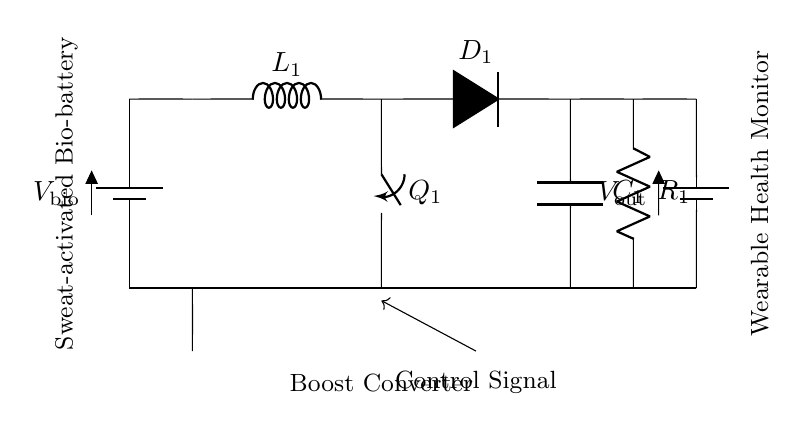What is the voltage of the bio-battery? The bio-battery provides a voltage labeled as V bio in the circuit diagram. It is the source for the circuit, supplying energy initially from the sweat-activated bio-battery.
Answer: V bio What type of inductor is used in the circuit? The circuit includes an inductor labeled as L1, which is responsible for storing energy in the boost converter configuration. It is highlighted as part of the boost converter section of the circuit.
Answer: L1 How many control signals are present in the circuit? There is one control signal indicated by an arrow pointing from the boost converter to the switch Q1, denoting its role in regulating charge flow.
Answer: One What component is used for energy storage after the inductor? A capacitor labeled C1 is specified right after the diode D1 and is part of the arrangement to stabilize the output voltage by smoothing out fluctuations after the boost conversion.
Answer: C1 What is the role of the switch in this circuit? The switch Q1 is used to control the flow of charge from the inductor L1 to the output, allowing for on/off regulation of power depending on the control signal. Its function is vital in the charging process.
Answer: Control What type of converter is utilized in this circuit? The circuit contains a boost converter, which is used to step up the voltage from the bio-battery before charging the wearable monitor, indicated by the specific arrangement of components including L1, D1, and C1.
Answer: Boost converter What is the purpose of resistor R1 in this circuit? Resistor R1 is used to control the charging current going into the wearable health monitor, helping to regulate the voltage output and charge performance according to the circuit requirements.
Answer: Current regulation 